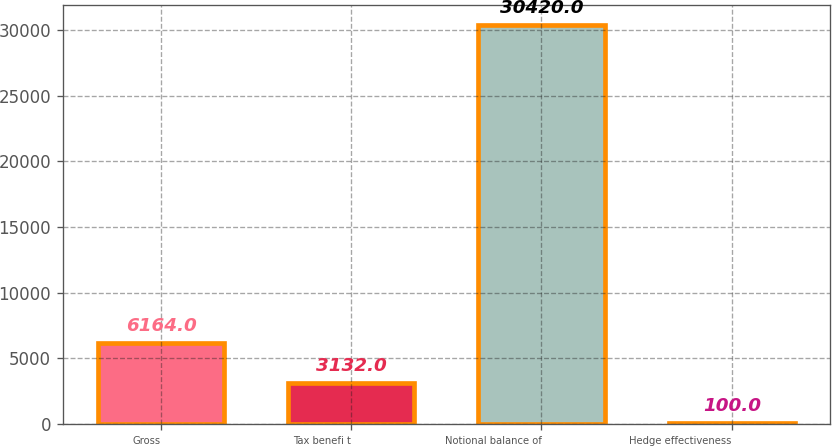<chart> <loc_0><loc_0><loc_500><loc_500><bar_chart><fcel>Gross<fcel>Tax benefi t<fcel>Notional balance of<fcel>Hedge effectiveness<nl><fcel>6164<fcel>3132<fcel>30420<fcel>100<nl></chart> 